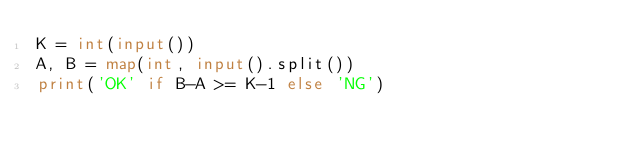Convert code to text. <code><loc_0><loc_0><loc_500><loc_500><_Python_>K = int(input())
A, B = map(int, input().split())
print('OK' if B-A >= K-1 else 'NG')</code> 